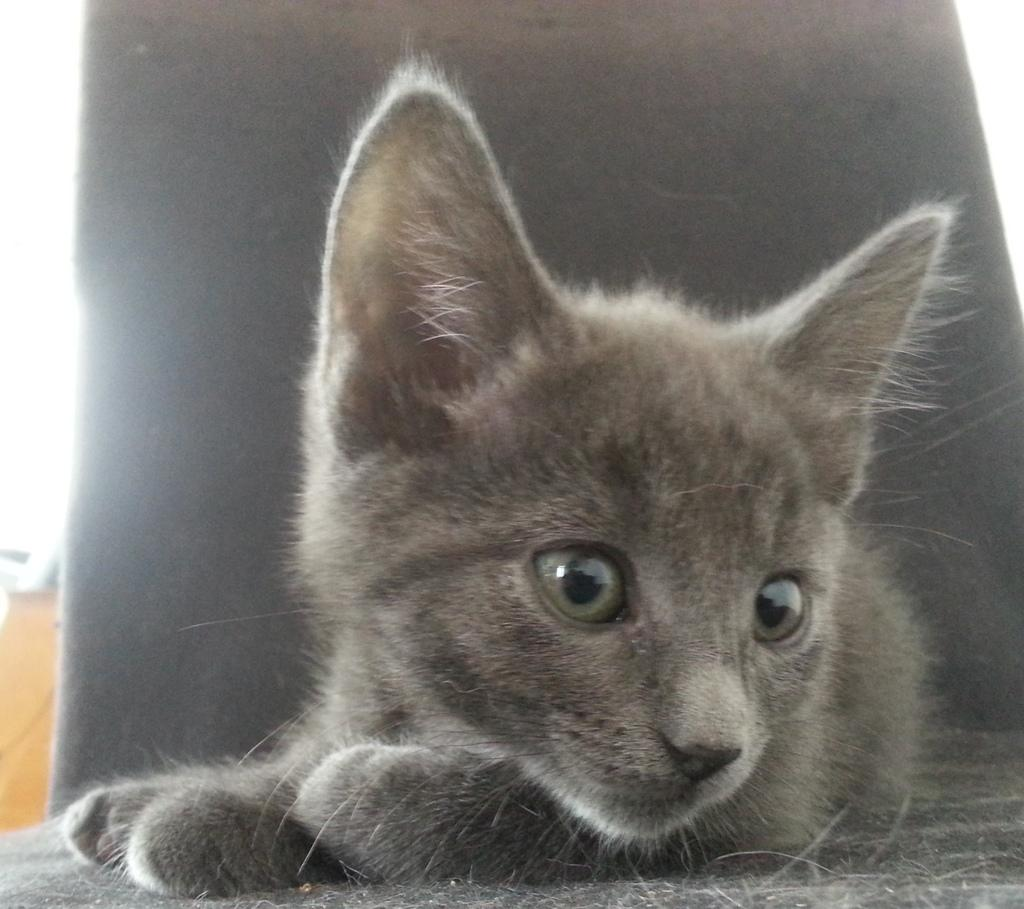What type of animal is present on the surface in the image? There is a cat on the surface in the image. What can be observed in the background of the image? The background of the image is grey. Where is the park located in the image? There is no park present in the image. What type of cheese is being used to create the picture in the image? There is no picture or cheese present in the image. 